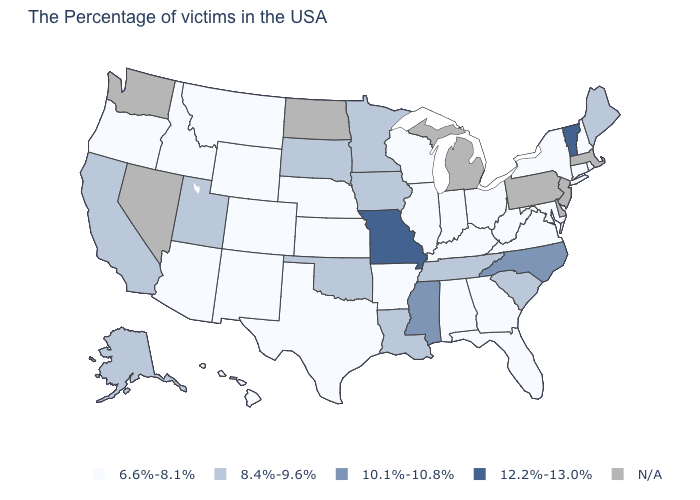Which states hav the highest value in the South?
Answer briefly. North Carolina, Mississippi. What is the value of Rhode Island?
Answer briefly. 6.6%-8.1%. How many symbols are there in the legend?
Concise answer only. 5. What is the value of Michigan?
Concise answer only. N/A. Name the states that have a value in the range 6.6%-8.1%?
Write a very short answer. Rhode Island, New Hampshire, Connecticut, New York, Maryland, Virginia, West Virginia, Ohio, Florida, Georgia, Kentucky, Indiana, Alabama, Wisconsin, Illinois, Arkansas, Kansas, Nebraska, Texas, Wyoming, Colorado, New Mexico, Montana, Arizona, Idaho, Oregon, Hawaii. What is the value of Kansas?
Quick response, please. 6.6%-8.1%. Name the states that have a value in the range 8.4%-9.6%?
Quick response, please. Maine, South Carolina, Tennessee, Louisiana, Minnesota, Iowa, Oklahoma, South Dakota, Utah, California, Alaska. What is the value of Ohio?
Keep it brief. 6.6%-8.1%. Is the legend a continuous bar?
Answer briefly. No. Name the states that have a value in the range 6.6%-8.1%?
Give a very brief answer. Rhode Island, New Hampshire, Connecticut, New York, Maryland, Virginia, West Virginia, Ohio, Florida, Georgia, Kentucky, Indiana, Alabama, Wisconsin, Illinois, Arkansas, Kansas, Nebraska, Texas, Wyoming, Colorado, New Mexico, Montana, Arizona, Idaho, Oregon, Hawaii. What is the value of North Dakota?
Short answer required. N/A. Does the first symbol in the legend represent the smallest category?
Write a very short answer. Yes. What is the value of Colorado?
Write a very short answer. 6.6%-8.1%. Name the states that have a value in the range 8.4%-9.6%?
Concise answer only. Maine, South Carolina, Tennessee, Louisiana, Minnesota, Iowa, Oklahoma, South Dakota, Utah, California, Alaska. Does Alaska have the lowest value in the West?
Concise answer only. No. 